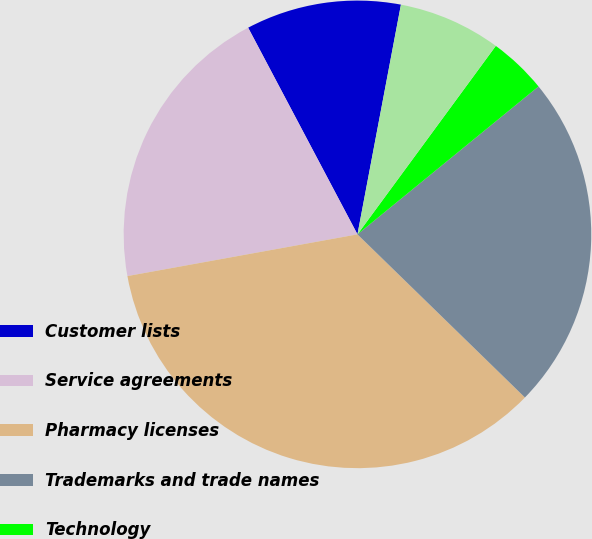<chart> <loc_0><loc_0><loc_500><loc_500><pie_chart><fcel>Customer lists<fcel>Service agreements<fcel>Pharmacy licenses<fcel>Trademarks and trade names<fcel>Technology<fcel>Other<nl><fcel>10.72%<fcel>20.11%<fcel>34.85%<fcel>23.19%<fcel>4.02%<fcel>7.1%<nl></chart> 